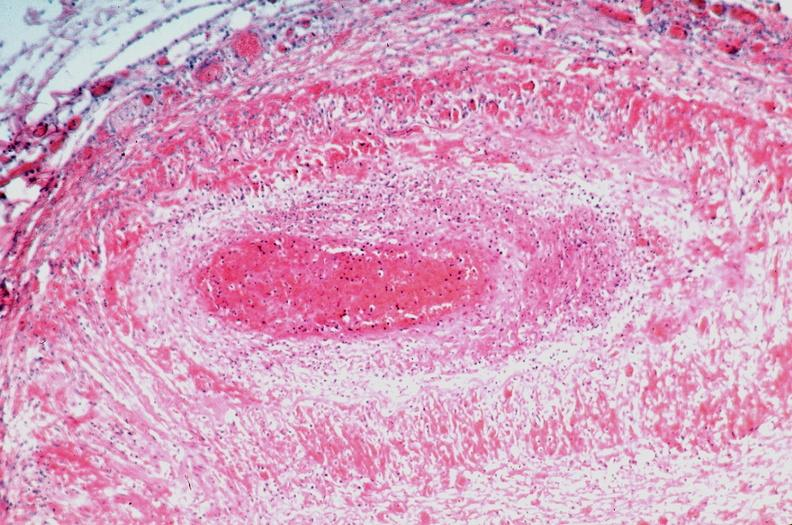what is present?
Answer the question using a single word or phrase. Vasculature 